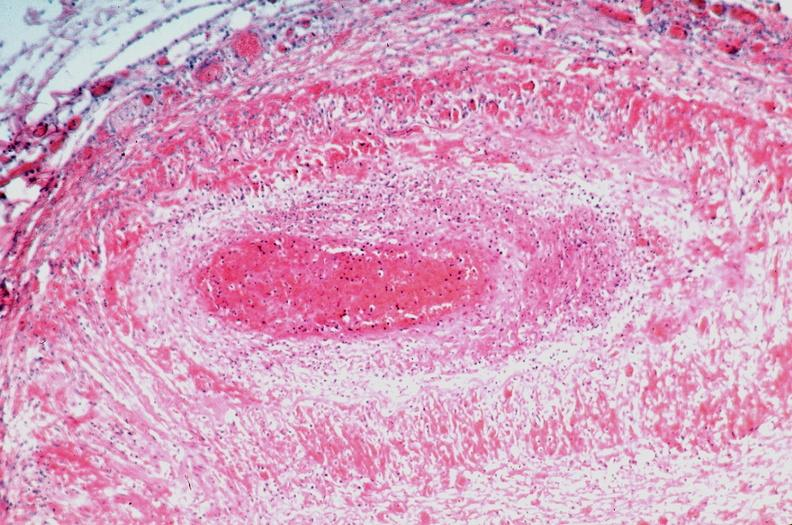what is present?
Answer the question using a single word or phrase. Vasculature 